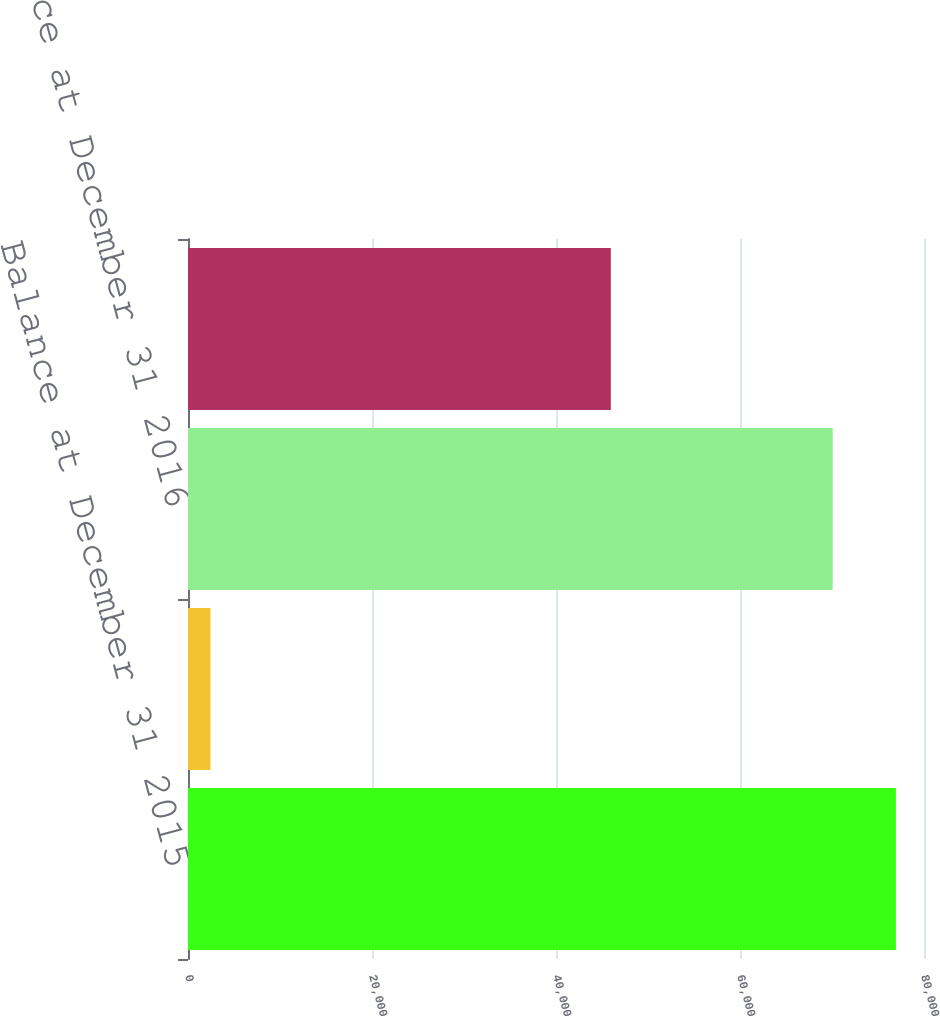Convert chart to OTSL. <chart><loc_0><loc_0><loc_500><loc_500><bar_chart><fcel>Balance at December 31 2015<fcel>Before-tax amount<fcel>Balance at December 31 2016<fcel>Balance at December 31 2017<nl><fcel>76948.5<fcel>2443<fcel>70075<fcel>45956<nl></chart> 